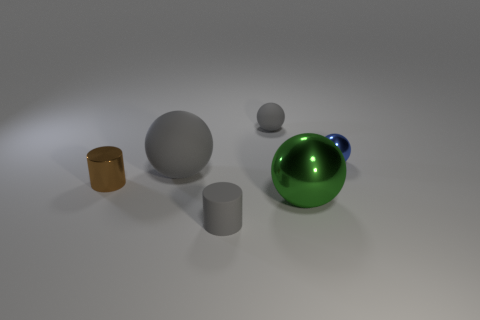How many other things are the same shape as the big metal thing?
Give a very brief answer. 3. Does the small shiny thing that is right of the green metallic ball have the same shape as the small rubber object that is behind the brown shiny cylinder?
Make the answer very short. Yes. What is the material of the small gray sphere?
Your answer should be very brief. Rubber. There is a sphere that is right of the large green thing; what is its material?
Provide a succinct answer. Metal. Are there any other things that are the same color as the large matte thing?
Your response must be concise. Yes. What is the size of the cylinder that is made of the same material as the blue sphere?
Your answer should be very brief. Small. How many tiny things are either cyan rubber balls or gray objects?
Ensure brevity in your answer.  2. There is a object on the left side of the large sphere that is on the left side of the small rubber thing that is behind the large shiny ball; what size is it?
Your answer should be compact. Small. How many other blue metal objects have the same size as the blue metal thing?
Provide a succinct answer. 0. How many objects are yellow objects or gray objects behind the gray cylinder?
Make the answer very short. 2. 